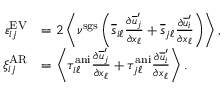<formula> <loc_0><loc_0><loc_500><loc_500>\begin{array} { r l } { \varepsilon _ { i j } ^ { E V } } & { = 2 \left < \nu ^ { s g s } \left ( \overline { s } _ { i \ell } \frac { \partial \overline { u } _ { j } ^ { \prime } } { \partial x _ { \ell } } + \overline { s } _ { j \ell } \frac { \partial \overline { u } _ { i } ^ { \prime } } { \partial x _ { \ell } } \right ) \right > , } \\ { \xi _ { i j } ^ { A R } } & { = \left < \tau _ { i \ell } ^ { a n i } \frac { \partial \overline { u } _ { j } ^ { \prime } } { \partial x _ { \ell } } + \tau _ { j \ell } ^ { a n i } \frac { \partial \overline { u } _ { i } ^ { \prime } } { \partial x _ { \ell } } \right > . } \end{array}</formula> 